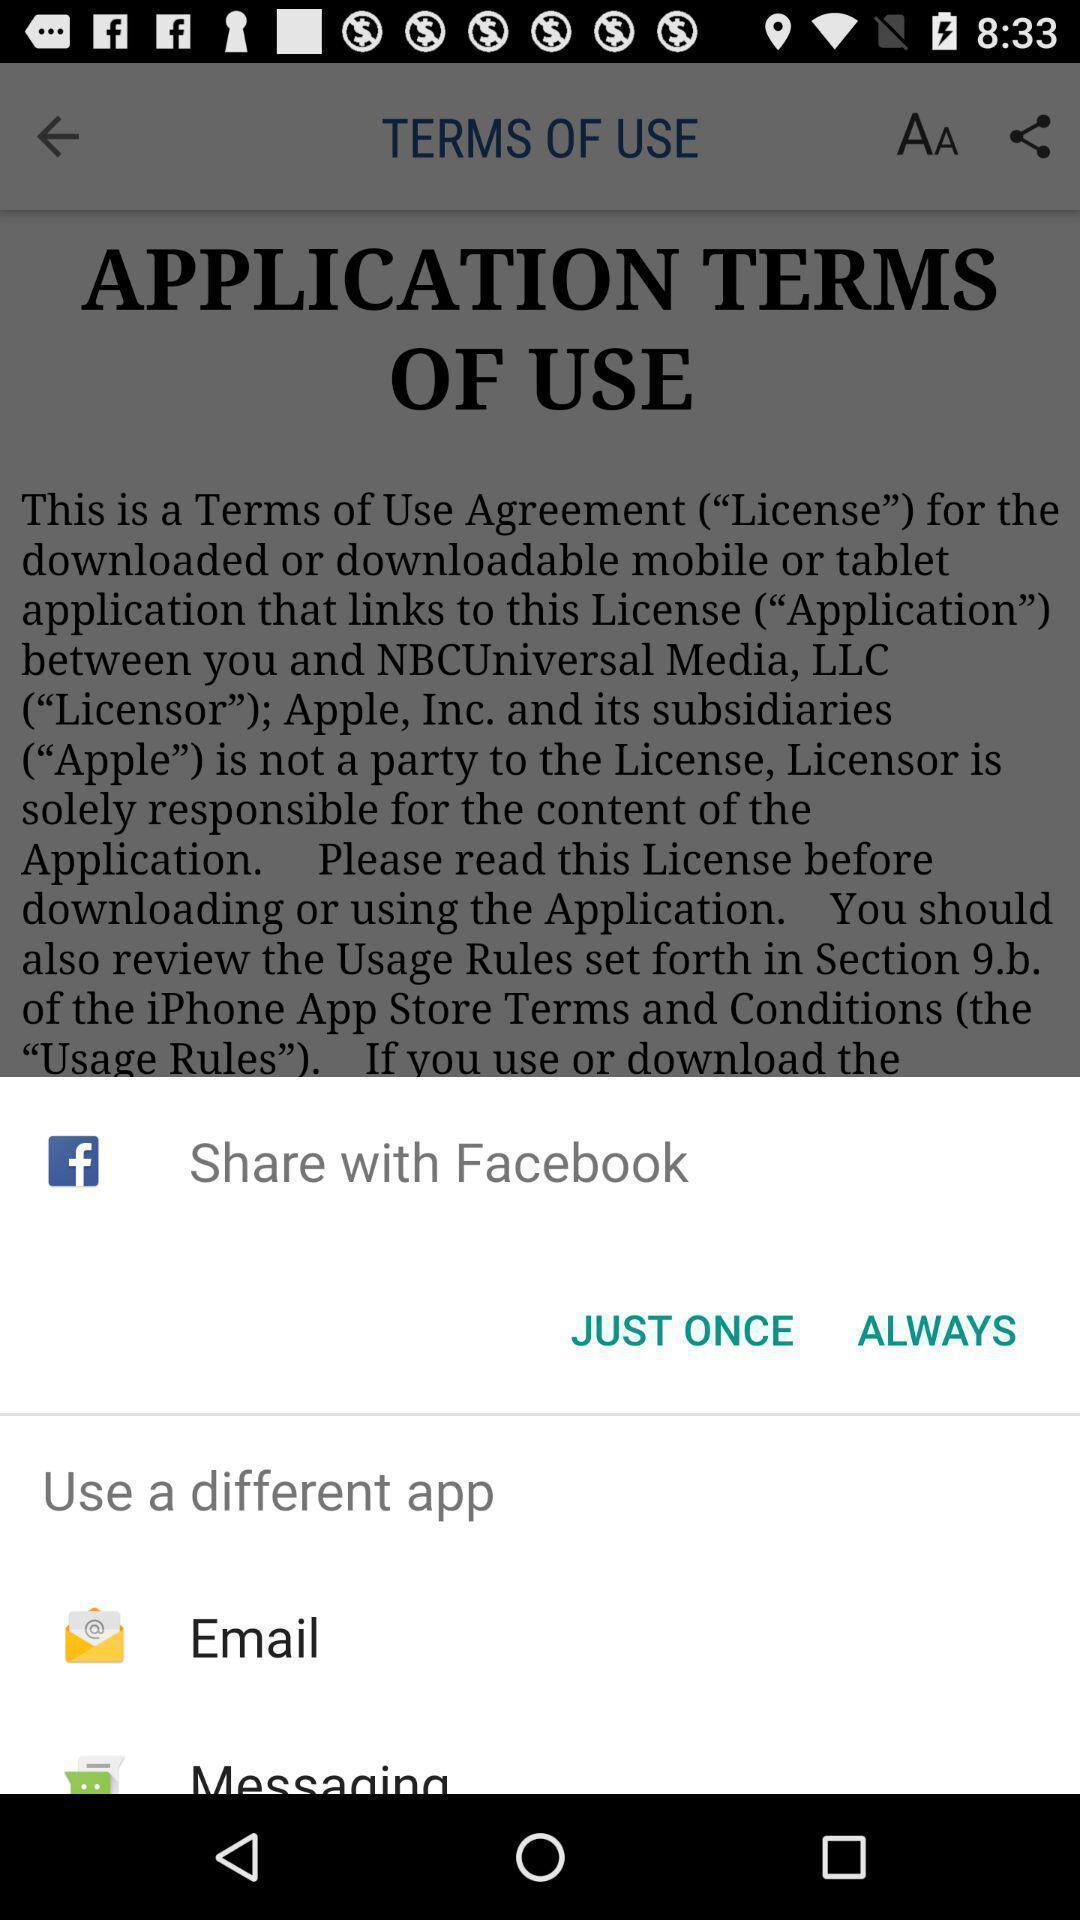What can you discern from this picture? Screen showing multiple applications to share. 